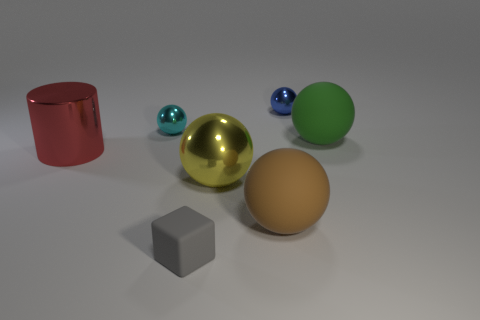Add 1 big objects. How many objects exist? 8 Subtract all big metallic balls. How many balls are left? 4 Subtract all brown balls. How many balls are left? 4 Subtract all cylinders. How many objects are left? 6 Subtract 1 spheres. How many spheres are left? 4 Subtract all purple cylinders. Subtract all purple cubes. How many cylinders are left? 1 Subtract all brown cylinders. How many yellow spheres are left? 1 Subtract all green matte cylinders. Subtract all tiny blue metallic balls. How many objects are left? 6 Add 7 large yellow things. How many large yellow things are left? 8 Add 3 shiny balls. How many shiny balls exist? 6 